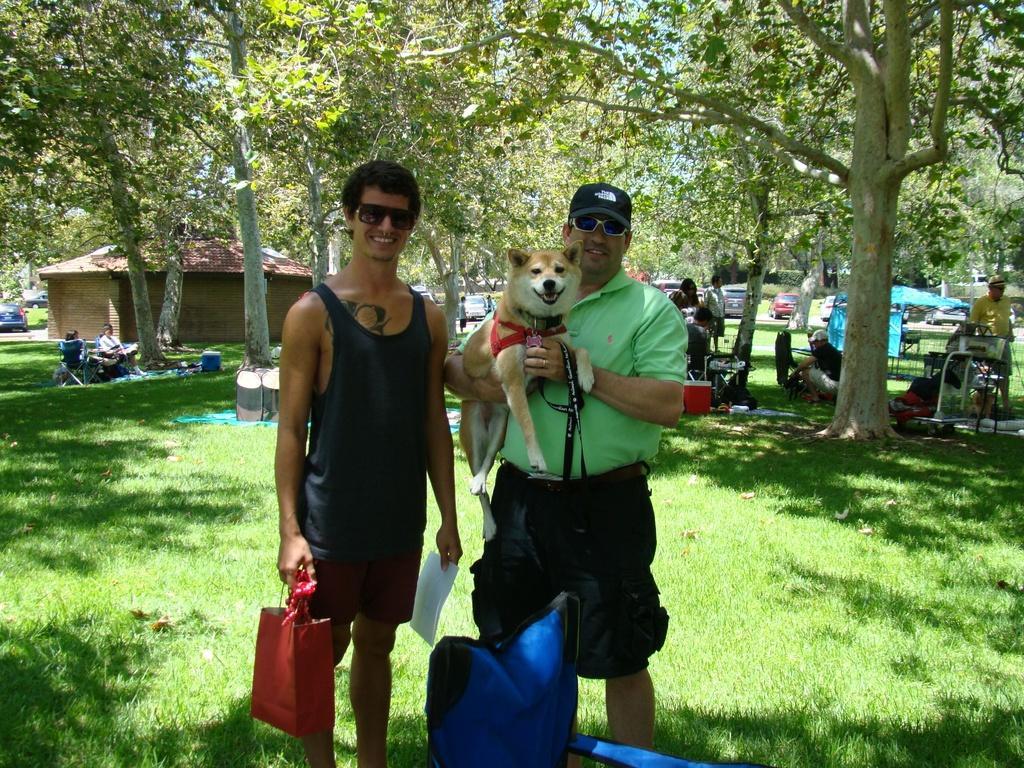Please provide a concise description of this image. This image is taken in outdoors. There are few people in this image. In the left side of the image there is a grass, a car and two people were sitting on a bench. In the right side of the image a man is standing. In the middle of the image two men are standing holding their things and dog in their hands. At the background there are many trees and a hut with roof. 